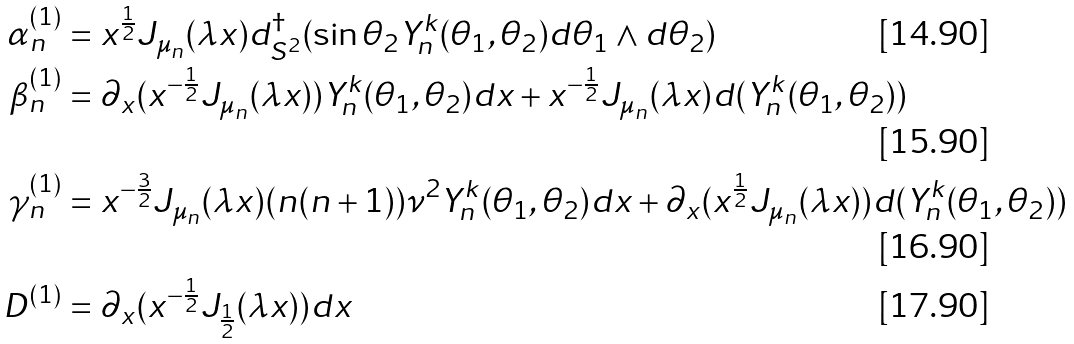Convert formula to latex. <formula><loc_0><loc_0><loc_500><loc_500>\alpha ^ { ( 1 ) } _ { n } & = x ^ { \frac { 1 } { 2 } } J _ { \mu _ { n } } ( \lambda x ) d ^ { \dag } _ { S ^ { 2 } } ( \sin \theta _ { 2 } Y ^ { k } _ { n } ( \theta _ { 1 } , \theta _ { 2 } ) d \theta _ { 1 } \wedge d \theta _ { 2 } ) \\ \beta ^ { ( 1 ) } _ { n } & = \partial _ { x } ( x ^ { - \frac { 1 } { 2 } } J _ { \mu _ { n } } ( \lambda x ) ) Y ^ { k } _ { n } ( \theta _ { 1 } , \theta _ { 2 } ) d x + x ^ { - \frac { 1 } { 2 } } J _ { \mu _ { n } } ( \lambda x ) d ( Y ^ { k } _ { n } ( \theta _ { 1 } , \theta _ { 2 } ) ) \\ \gamma ^ { ( 1 ) } _ { n } & = x ^ { - \frac { 3 } { 2 } } J _ { \mu _ { n } } ( \lambda x ) ( n ( n + 1 ) ) \nu ^ { 2 } Y ^ { k } _ { n } ( \theta _ { 1 } , \theta _ { 2 } ) d x + \partial _ { x } ( x ^ { \frac { 1 } { 2 } } J _ { \mu _ { n } } ( \lambda x ) ) d ( Y ^ { k } _ { n } ( \theta _ { 1 } , \theta _ { 2 } ) ) \\ D ^ { ( 1 ) } & = \partial _ { x } ( x ^ { - \frac { 1 } { 2 } } J _ { \frac { 1 } { 2 } } ( \lambda x ) ) d x</formula> 